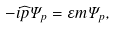<formula> <loc_0><loc_0><loc_500><loc_500>- i \widehat { p } \Psi _ { p } = \varepsilon m \Psi _ { p } ,</formula> 